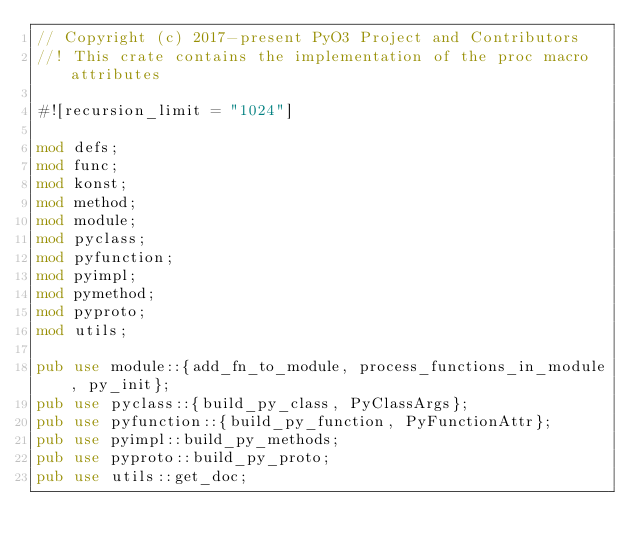<code> <loc_0><loc_0><loc_500><loc_500><_Rust_>// Copyright (c) 2017-present PyO3 Project and Contributors
//! This crate contains the implementation of the proc macro attributes

#![recursion_limit = "1024"]

mod defs;
mod func;
mod konst;
mod method;
mod module;
mod pyclass;
mod pyfunction;
mod pyimpl;
mod pymethod;
mod pyproto;
mod utils;

pub use module::{add_fn_to_module, process_functions_in_module, py_init};
pub use pyclass::{build_py_class, PyClassArgs};
pub use pyfunction::{build_py_function, PyFunctionAttr};
pub use pyimpl::build_py_methods;
pub use pyproto::build_py_proto;
pub use utils::get_doc;
</code> 